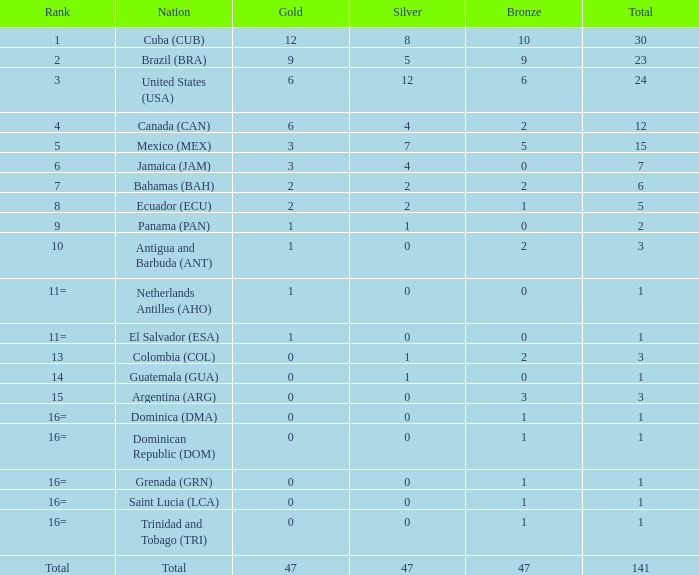How many bronzes have a Nation of jamaica (jam), and a Total smaller than 7? 0.0. 